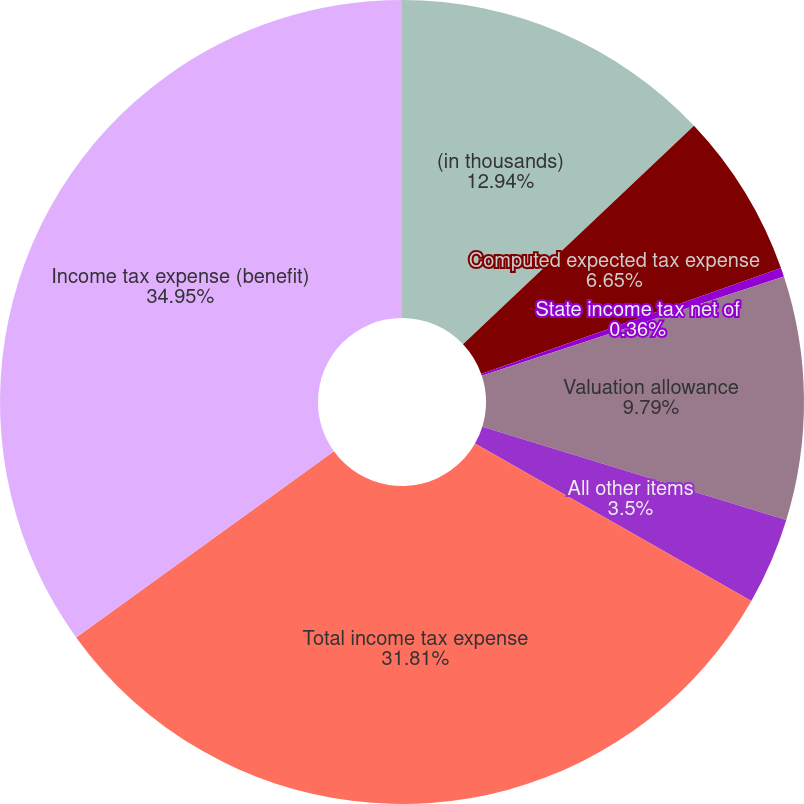Convert chart. <chart><loc_0><loc_0><loc_500><loc_500><pie_chart><fcel>(in thousands)<fcel>Computed expected tax expense<fcel>State income tax net of<fcel>Valuation allowance<fcel>All other items<fcel>Total income tax expense<fcel>Income tax expense (benefit)<nl><fcel>12.94%<fcel>6.65%<fcel>0.36%<fcel>9.79%<fcel>3.5%<fcel>31.81%<fcel>34.96%<nl></chart> 